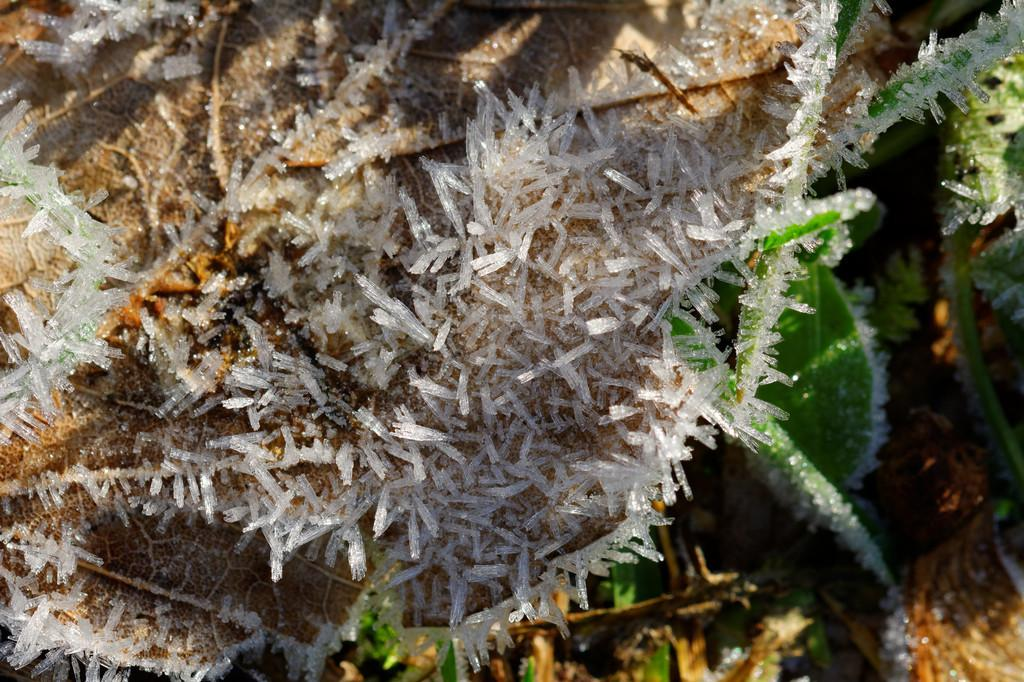What type of underwater environment is depicted in the image? There are coral reefs in the image. Can you describe the colors and patterns of the coral reefs? The coral reefs in the image display a variety of colors and patterns. What type of marine life might be found near the coral reefs in the image? The image does not show specific marine life, but coral reefs are known to support a diverse range of marine species. What songs are being sung by the coral reefs in the image? Coral reefs do not sing songs, as they are inanimate underwater structures. 